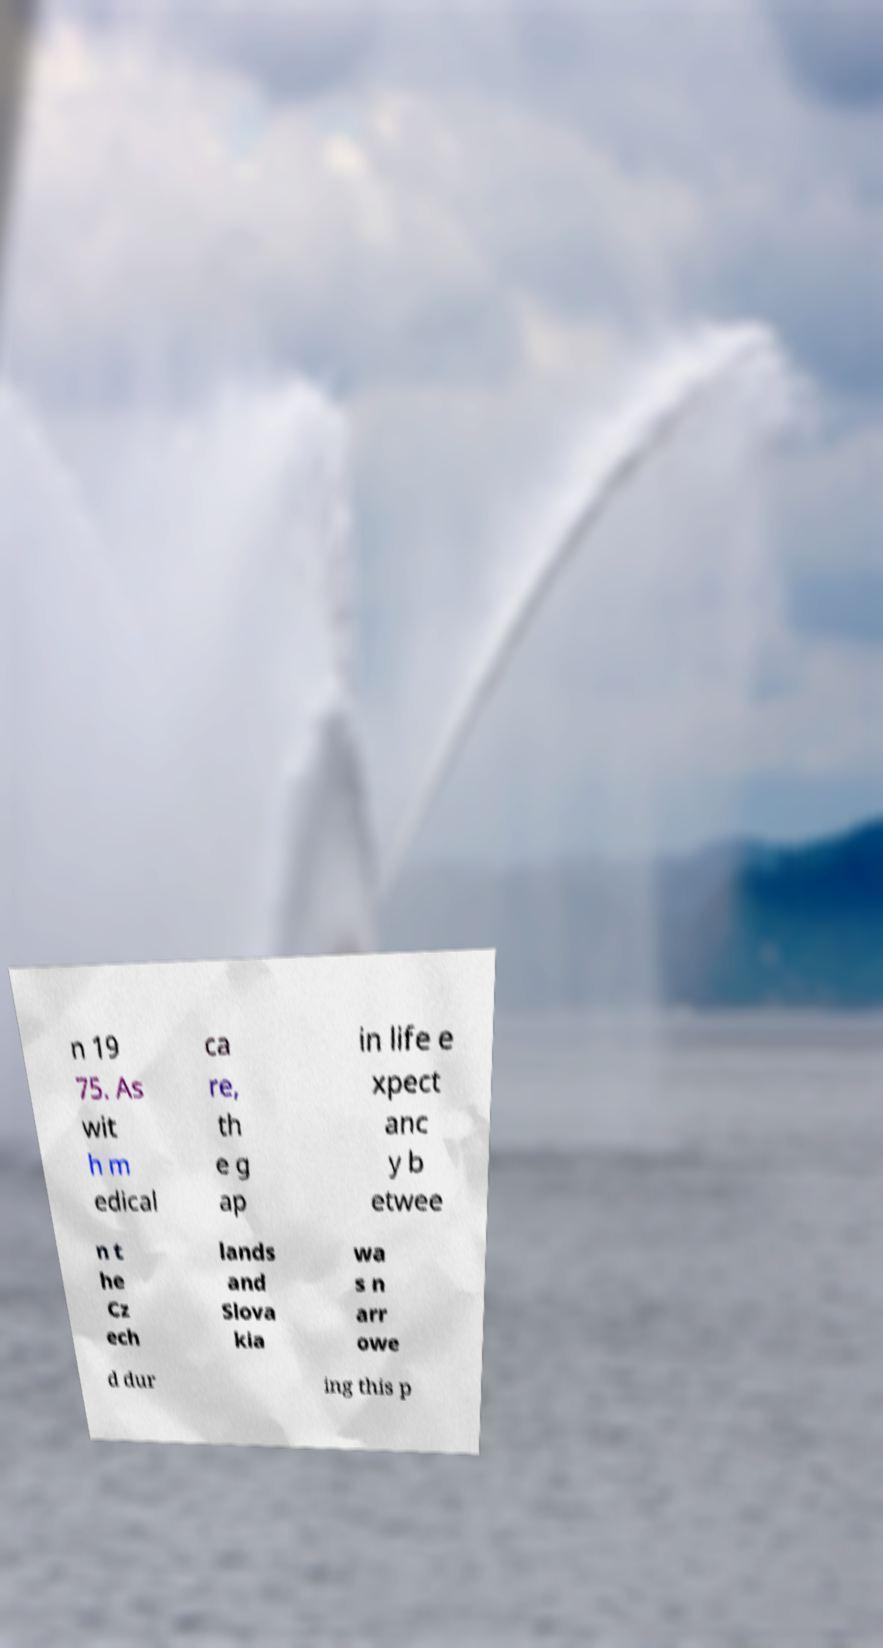What messages or text are displayed in this image? I need them in a readable, typed format. n 19 75. As wit h m edical ca re, th e g ap in life e xpect anc y b etwee n t he Cz ech lands and Slova kia wa s n arr owe d dur ing this p 